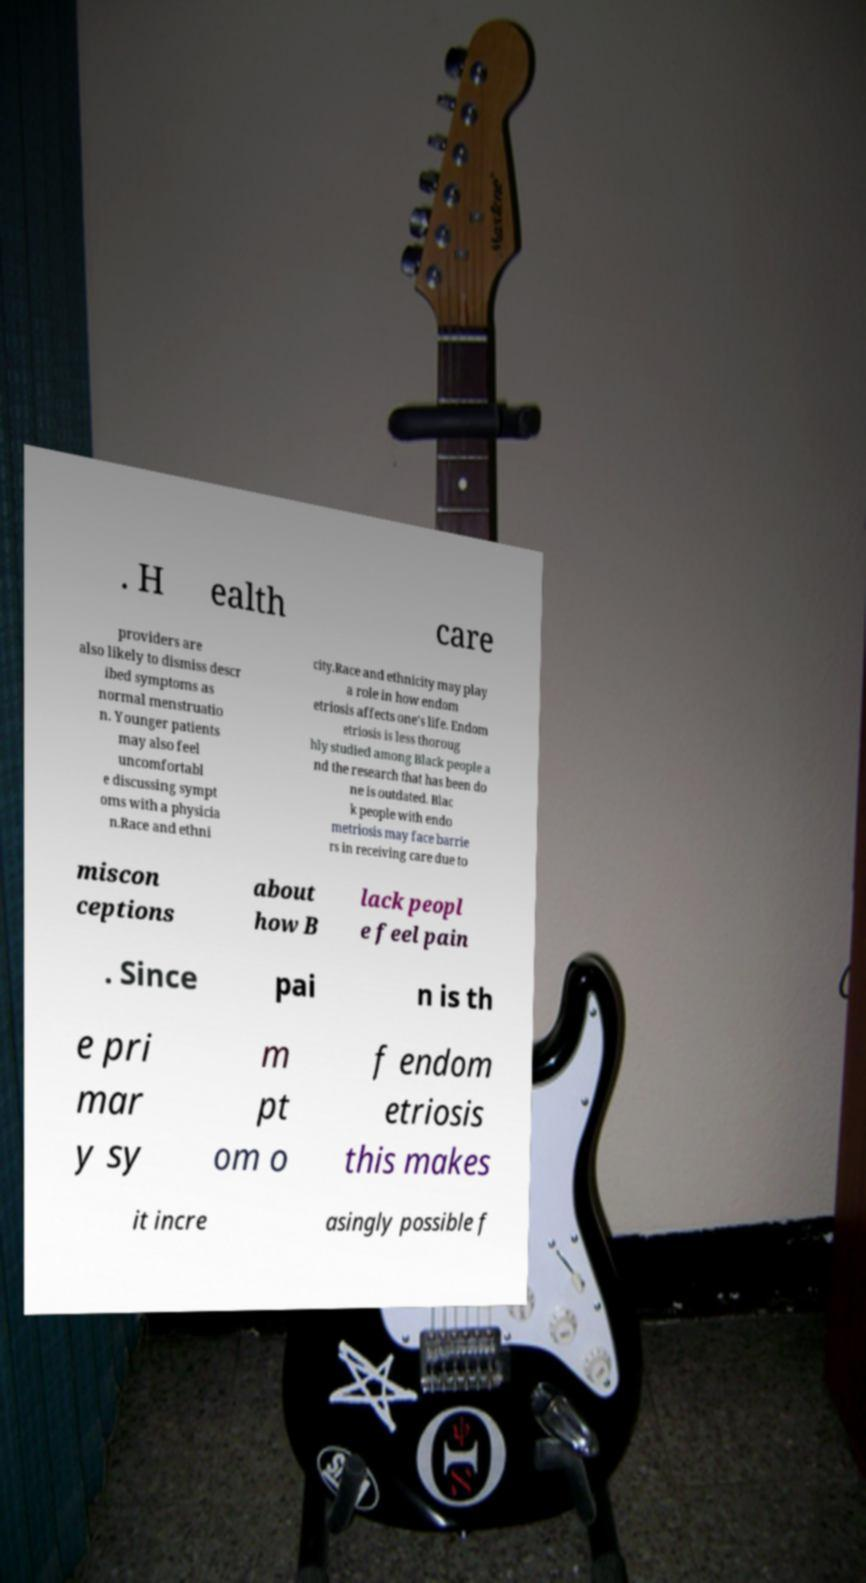Can you read and provide the text displayed in the image?This photo seems to have some interesting text. Can you extract and type it out for me? . H ealth care providers are also likely to dismiss descr ibed symptoms as normal menstruatio n. Younger patients may also feel uncomfortabl e discussing sympt oms with a physicia n.Race and ethni city.Race and ethnicity may play a role in how endom etriosis affects one's life. Endom etriosis is less thoroug hly studied among Black people a nd the research that has been do ne is outdated. Blac k people with endo metriosis may face barrie rs in receiving care due to miscon ceptions about how B lack peopl e feel pain . Since pai n is th e pri mar y sy m pt om o f endom etriosis this makes it incre asingly possible f 